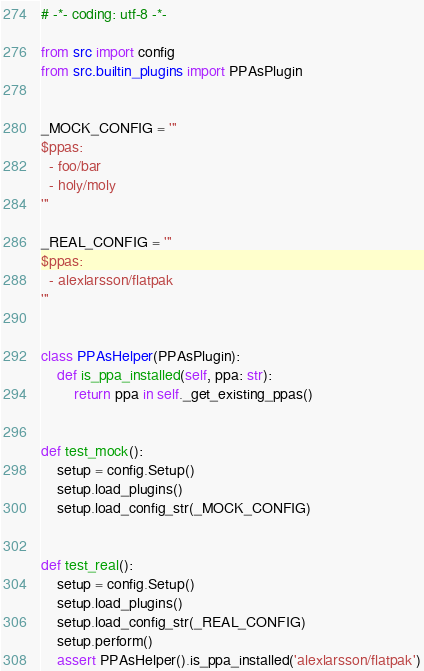Convert code to text. <code><loc_0><loc_0><loc_500><loc_500><_Python_># -*- coding: utf-8 -*-

from src import config
from src.builtin_plugins import PPAsPlugin


_MOCK_CONFIG = '''
$ppas:
  - foo/bar
  - holy/moly
'''

_REAL_CONFIG = '''
$ppas:
  - alexlarsson/flatpak
'''


class PPAsHelper(PPAsPlugin):
    def is_ppa_installed(self, ppa: str):
        return ppa in self._get_existing_ppas()


def test_mock():
    setup = config.Setup()
    setup.load_plugins()
    setup.load_config_str(_MOCK_CONFIG)


def test_real():
    setup = config.Setup()
    setup.load_plugins()
    setup.load_config_str(_REAL_CONFIG)
    setup.perform()
    assert PPAsHelper().is_ppa_installed('alexlarsson/flatpak')
</code> 